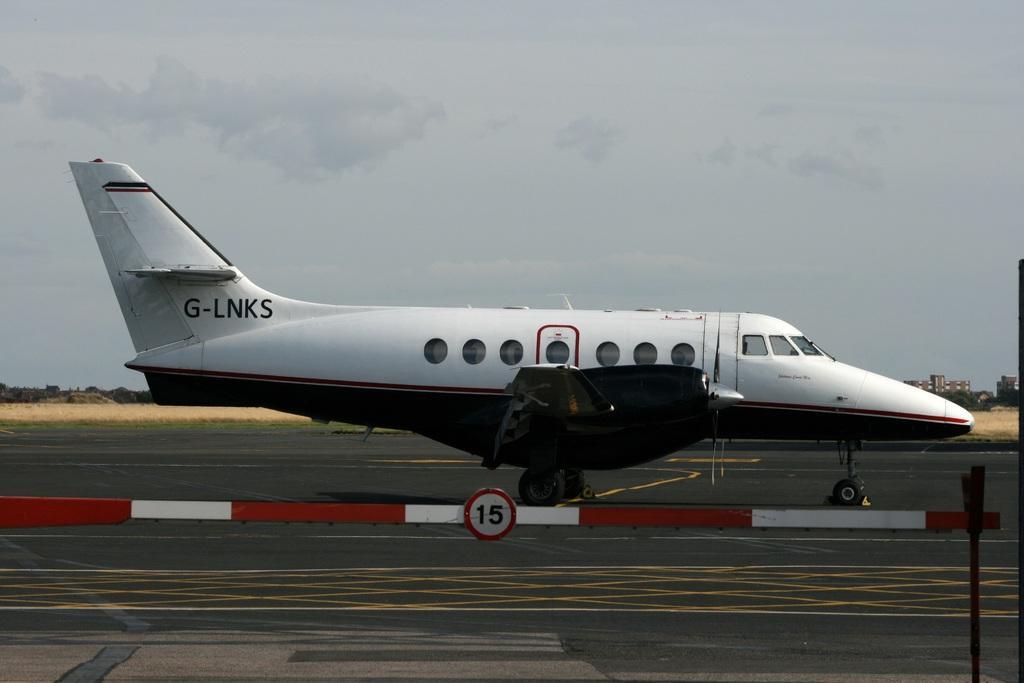Could you give a brief overview of what you see in this image? In the image I can see a white color airplane on the road. In the background I can see buildings, trees and the sky. 